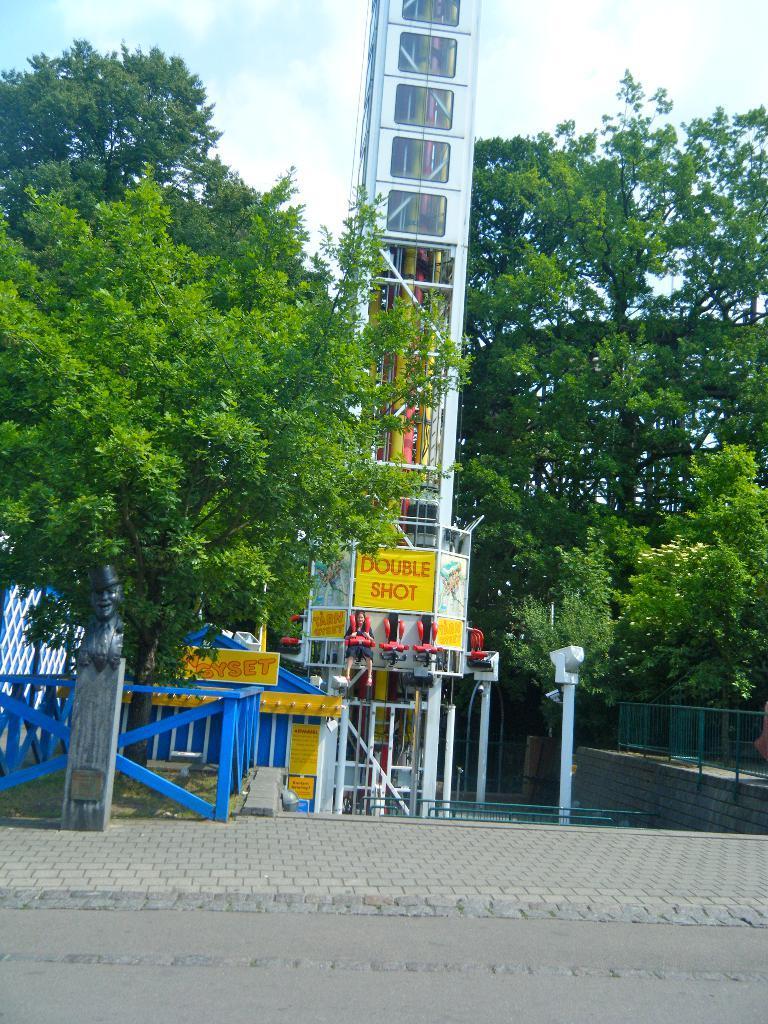Could you give a brief overview of what you see in this image? There is a road with sidewalk. On the left side there is a statue on a stand. There are poles, railing and a wall. Also there is a pillar with pipes. And there are trees. In the background there is sky. 